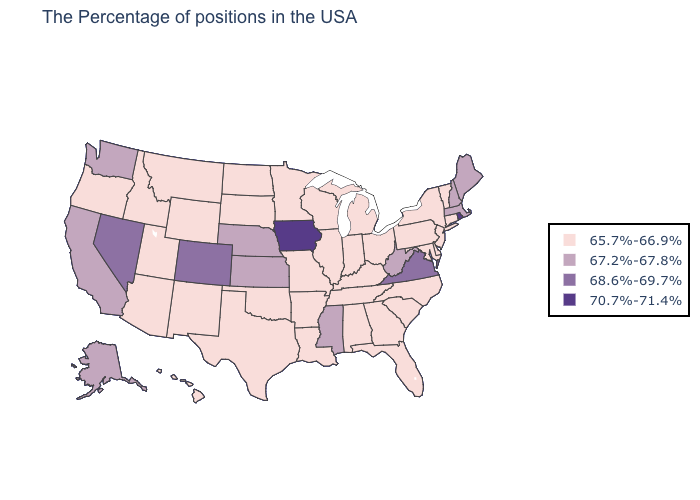Does Arkansas have a lower value than Oklahoma?
Concise answer only. No. What is the value of Pennsylvania?
Keep it brief. 65.7%-66.9%. Which states have the highest value in the USA?
Write a very short answer. Rhode Island, Iowa. Does New Hampshire have the highest value in the USA?
Give a very brief answer. No. Which states have the lowest value in the West?
Keep it brief. Wyoming, New Mexico, Utah, Montana, Arizona, Idaho, Oregon, Hawaii. Does New York have the highest value in the Northeast?
Keep it brief. No. What is the lowest value in states that border Indiana?
Answer briefly. 65.7%-66.9%. Name the states that have a value in the range 70.7%-71.4%?
Short answer required. Rhode Island, Iowa. What is the highest value in states that border Kansas?
Give a very brief answer. 68.6%-69.7%. Name the states that have a value in the range 68.6%-69.7%?
Write a very short answer. Virginia, Colorado, Nevada. Among the states that border Arkansas , which have the highest value?
Answer briefly. Mississippi. What is the highest value in states that border Vermont?
Keep it brief. 67.2%-67.8%. Among the states that border Tennessee , does Virginia have the lowest value?
Be succinct. No. Does the first symbol in the legend represent the smallest category?
Give a very brief answer. Yes. Does Arizona have a lower value than Texas?
Give a very brief answer. No. 